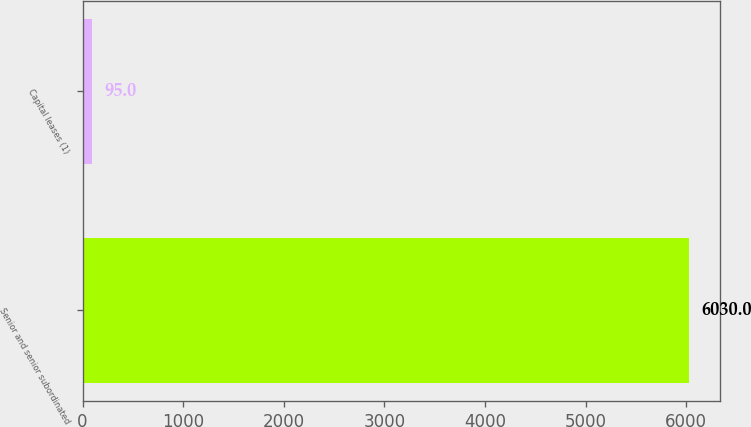Convert chart. <chart><loc_0><loc_0><loc_500><loc_500><bar_chart><fcel>Senior and senior subordinated<fcel>Capital leases (1)<nl><fcel>6030<fcel>95<nl></chart> 